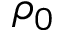<formula> <loc_0><loc_0><loc_500><loc_500>\rho _ { 0 }</formula> 